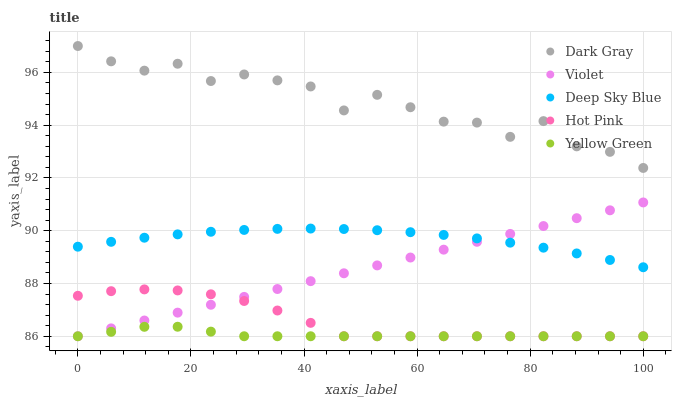Does Yellow Green have the minimum area under the curve?
Answer yes or no. Yes. Does Dark Gray have the maximum area under the curve?
Answer yes or no. Yes. Does Hot Pink have the minimum area under the curve?
Answer yes or no. No. Does Hot Pink have the maximum area under the curve?
Answer yes or no. No. Is Violet the smoothest?
Answer yes or no. Yes. Is Dark Gray the roughest?
Answer yes or no. Yes. Is Hot Pink the smoothest?
Answer yes or no. No. Is Hot Pink the roughest?
Answer yes or no. No. Does Hot Pink have the lowest value?
Answer yes or no. Yes. Does Deep Sky Blue have the lowest value?
Answer yes or no. No. Does Dark Gray have the highest value?
Answer yes or no. Yes. Does Hot Pink have the highest value?
Answer yes or no. No. Is Hot Pink less than Deep Sky Blue?
Answer yes or no. Yes. Is Deep Sky Blue greater than Yellow Green?
Answer yes or no. Yes. Does Violet intersect Hot Pink?
Answer yes or no. Yes. Is Violet less than Hot Pink?
Answer yes or no. No. Is Violet greater than Hot Pink?
Answer yes or no. No. Does Hot Pink intersect Deep Sky Blue?
Answer yes or no. No. 